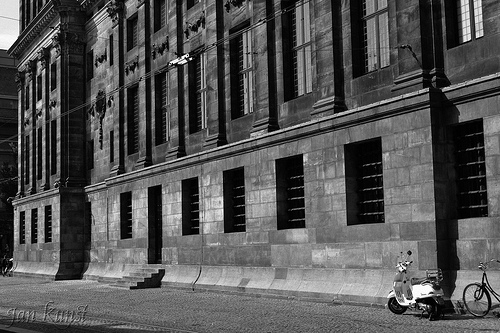Is there a window in this scene? Yes, there are several windows. 